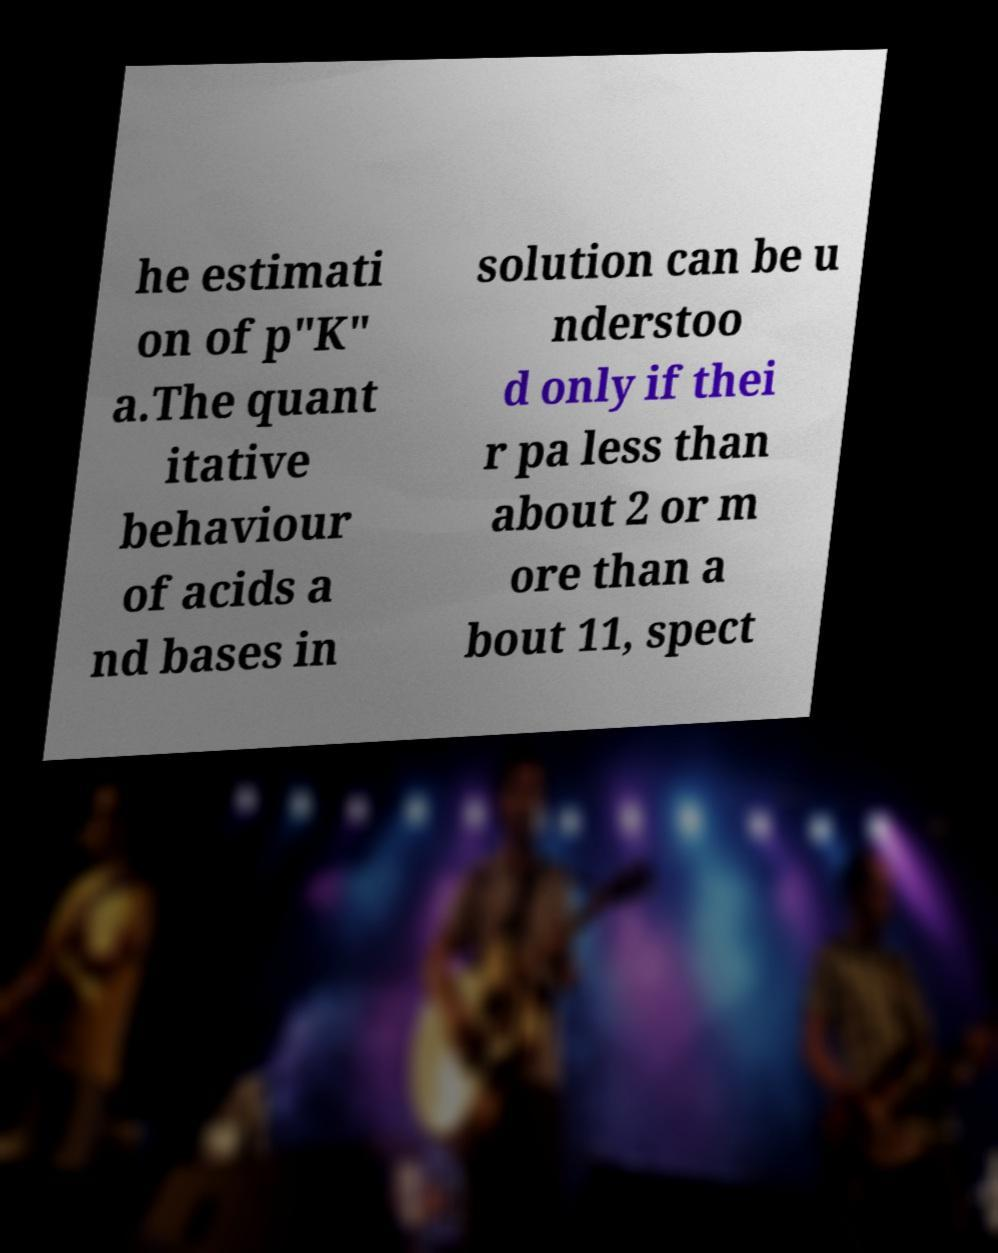There's text embedded in this image that I need extracted. Can you transcribe it verbatim? he estimati on of p"K" a.The quant itative behaviour of acids a nd bases in solution can be u nderstoo d only if thei r pa less than about 2 or m ore than a bout 11, spect 